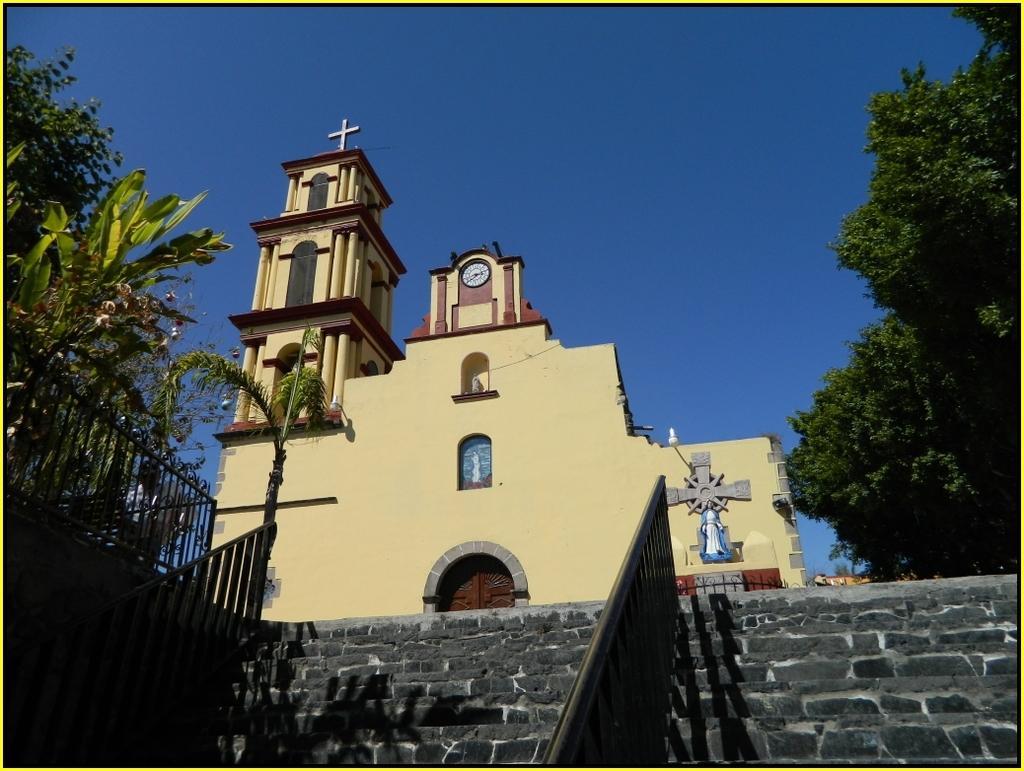Could you give a brief overview of what you see in this image? At the bottom of the image there are some steps and fencing. In the middle of the image there is a building. Behind the building there is sky. On the left side of the image there are some trees. On the right side of the image there are some trees. 